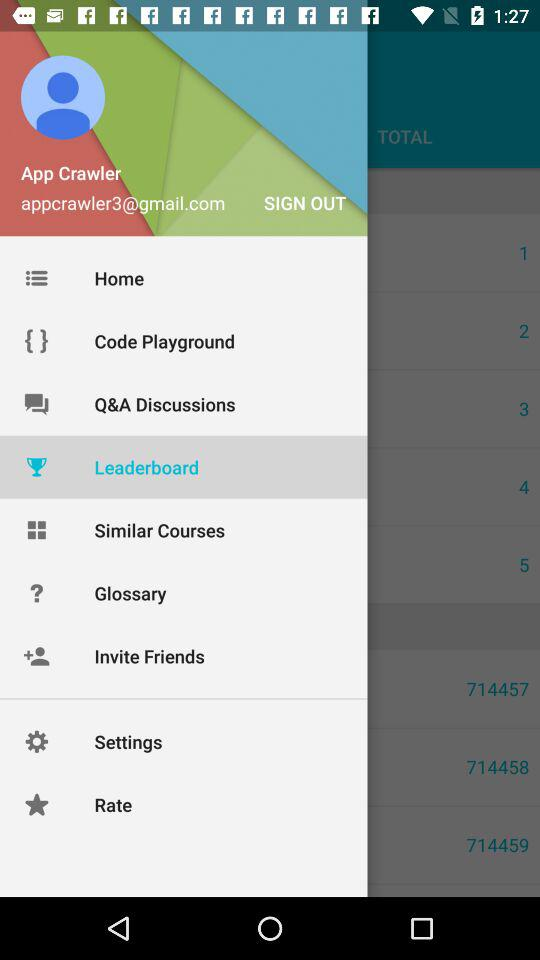What is the name of the user? The name of the user is App Crawler. 